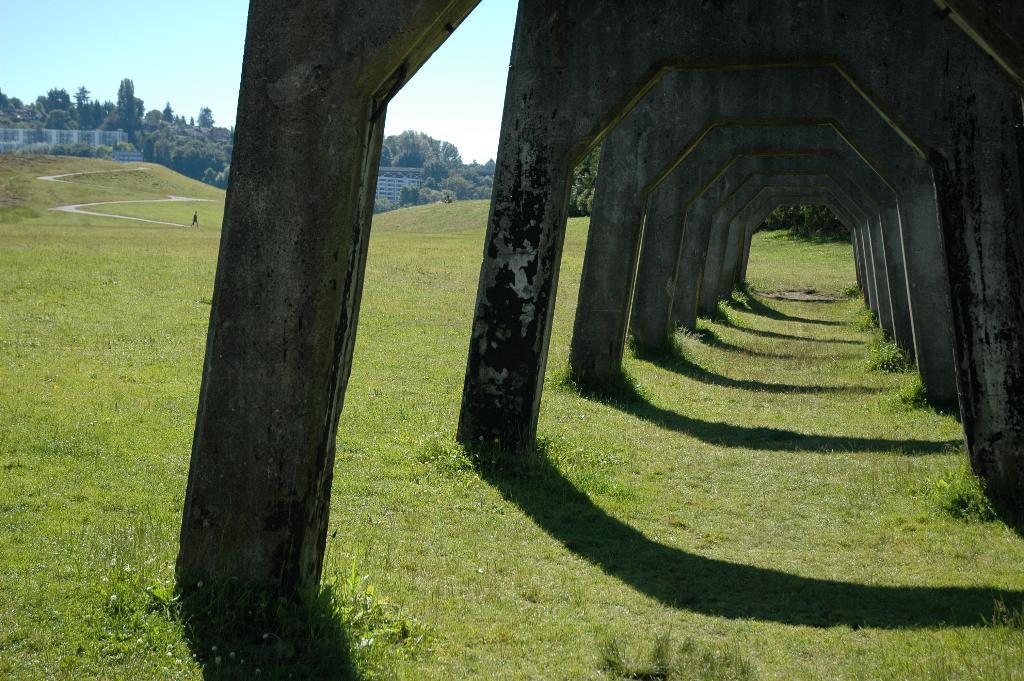Please provide a concise description of this image. In this image I can see the ground, some grass on the ground and number of pillars on the ground. In the background I can see a person standing on the ground, few buildings, few trees, the path and the sky. 